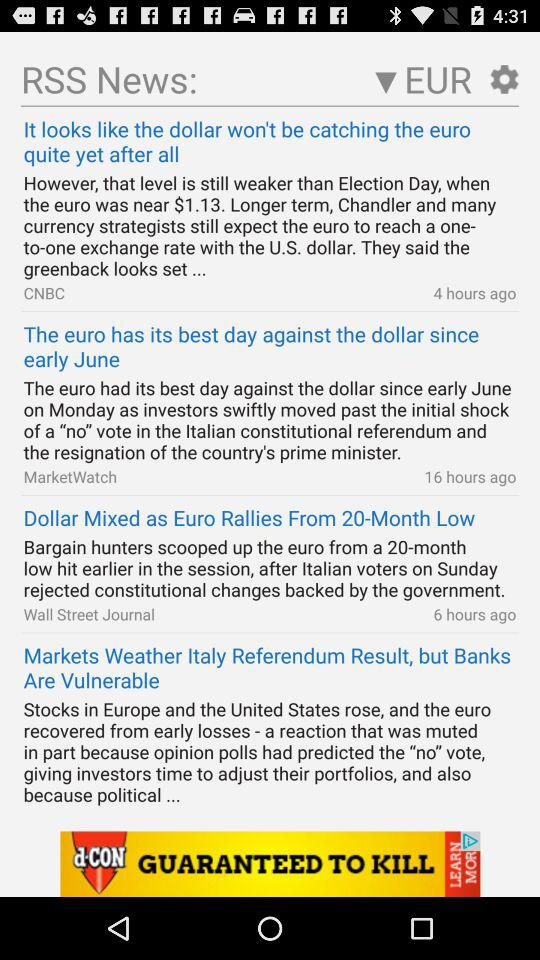On which channel was the "It looks like the dollar won't be catching the euro quite yet after all" news posted? The news was updated on CNBC. 